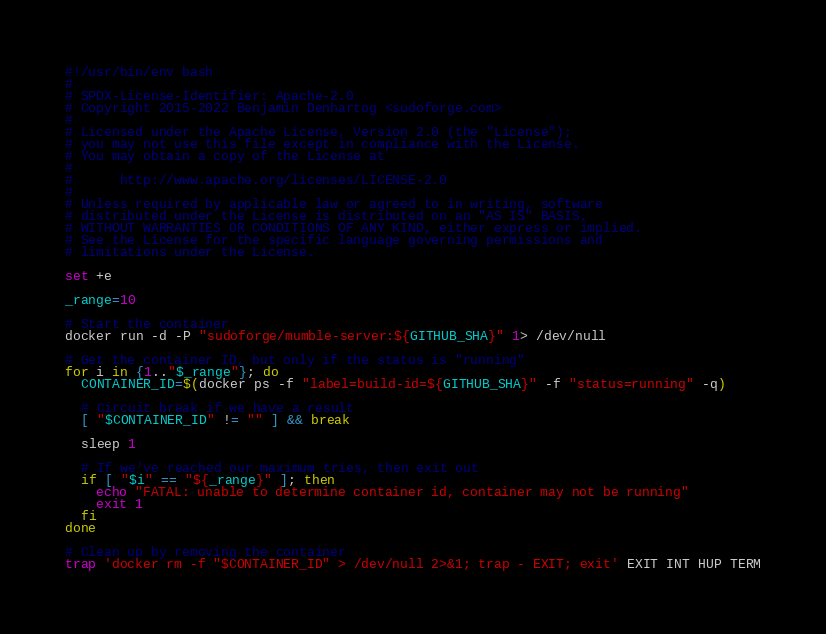<code> <loc_0><loc_0><loc_500><loc_500><_Bash_>#!/usr/bin/env bash
#
# SPDX-License-Identifier: Apache-2.0
# Copyright 2015-2022 Benjamin Denhartog <sudoforge.com>
#
# Licensed under the Apache License, Version 2.0 (the "License");
# you may not use this file except in compliance with the License.
# You may obtain a copy of the License at
#
#      http://www.apache.org/licenses/LICENSE-2.0
#
# Unless required by applicable law or agreed to in writing, software
# distributed under the License is distributed on an "AS IS" BASIS,
# WITHOUT WARRANTIES OR CONDITIONS OF ANY KIND, either express or implied.
# See the License for the specific language governing permissions and
# limitations under the License.

set +e

_range=10

# Start the container
docker run -d -P "sudoforge/mumble-server:${GITHUB_SHA}" 1> /dev/null

# Get the container ID, but only if the status is "running"
for i in {1.."$_range"}; do
  CONTAINER_ID=$(docker ps -f "label=build-id=${GITHUB_SHA}" -f "status=running" -q)

  # Circuit break if we have a result
  [ "$CONTAINER_ID" != "" ] && break

  sleep 1

  # If we've reached our maximum tries, then exit out
  if [ "$i" == "${_range}" ]; then
    echo "FATAL: unable to determine container id, container may not be running"
    exit 1
  fi
done

# Clean up by removing the container
trap 'docker rm -f "$CONTAINER_ID" > /dev/null 2>&1; trap - EXIT; exit' EXIT INT HUP TERM
</code> 